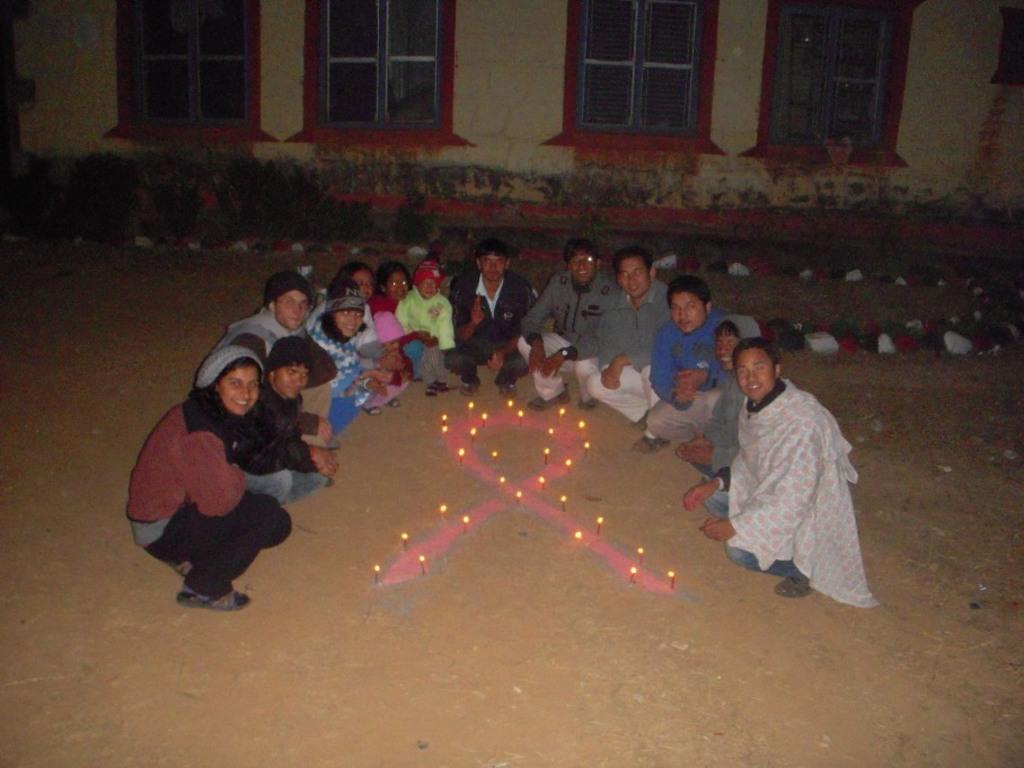Could you give a brief overview of what you see in this image? In this image we can see some group of persons crouching down on the ground, there are some candles on the ground and in the background of the image there is house and some plants. 